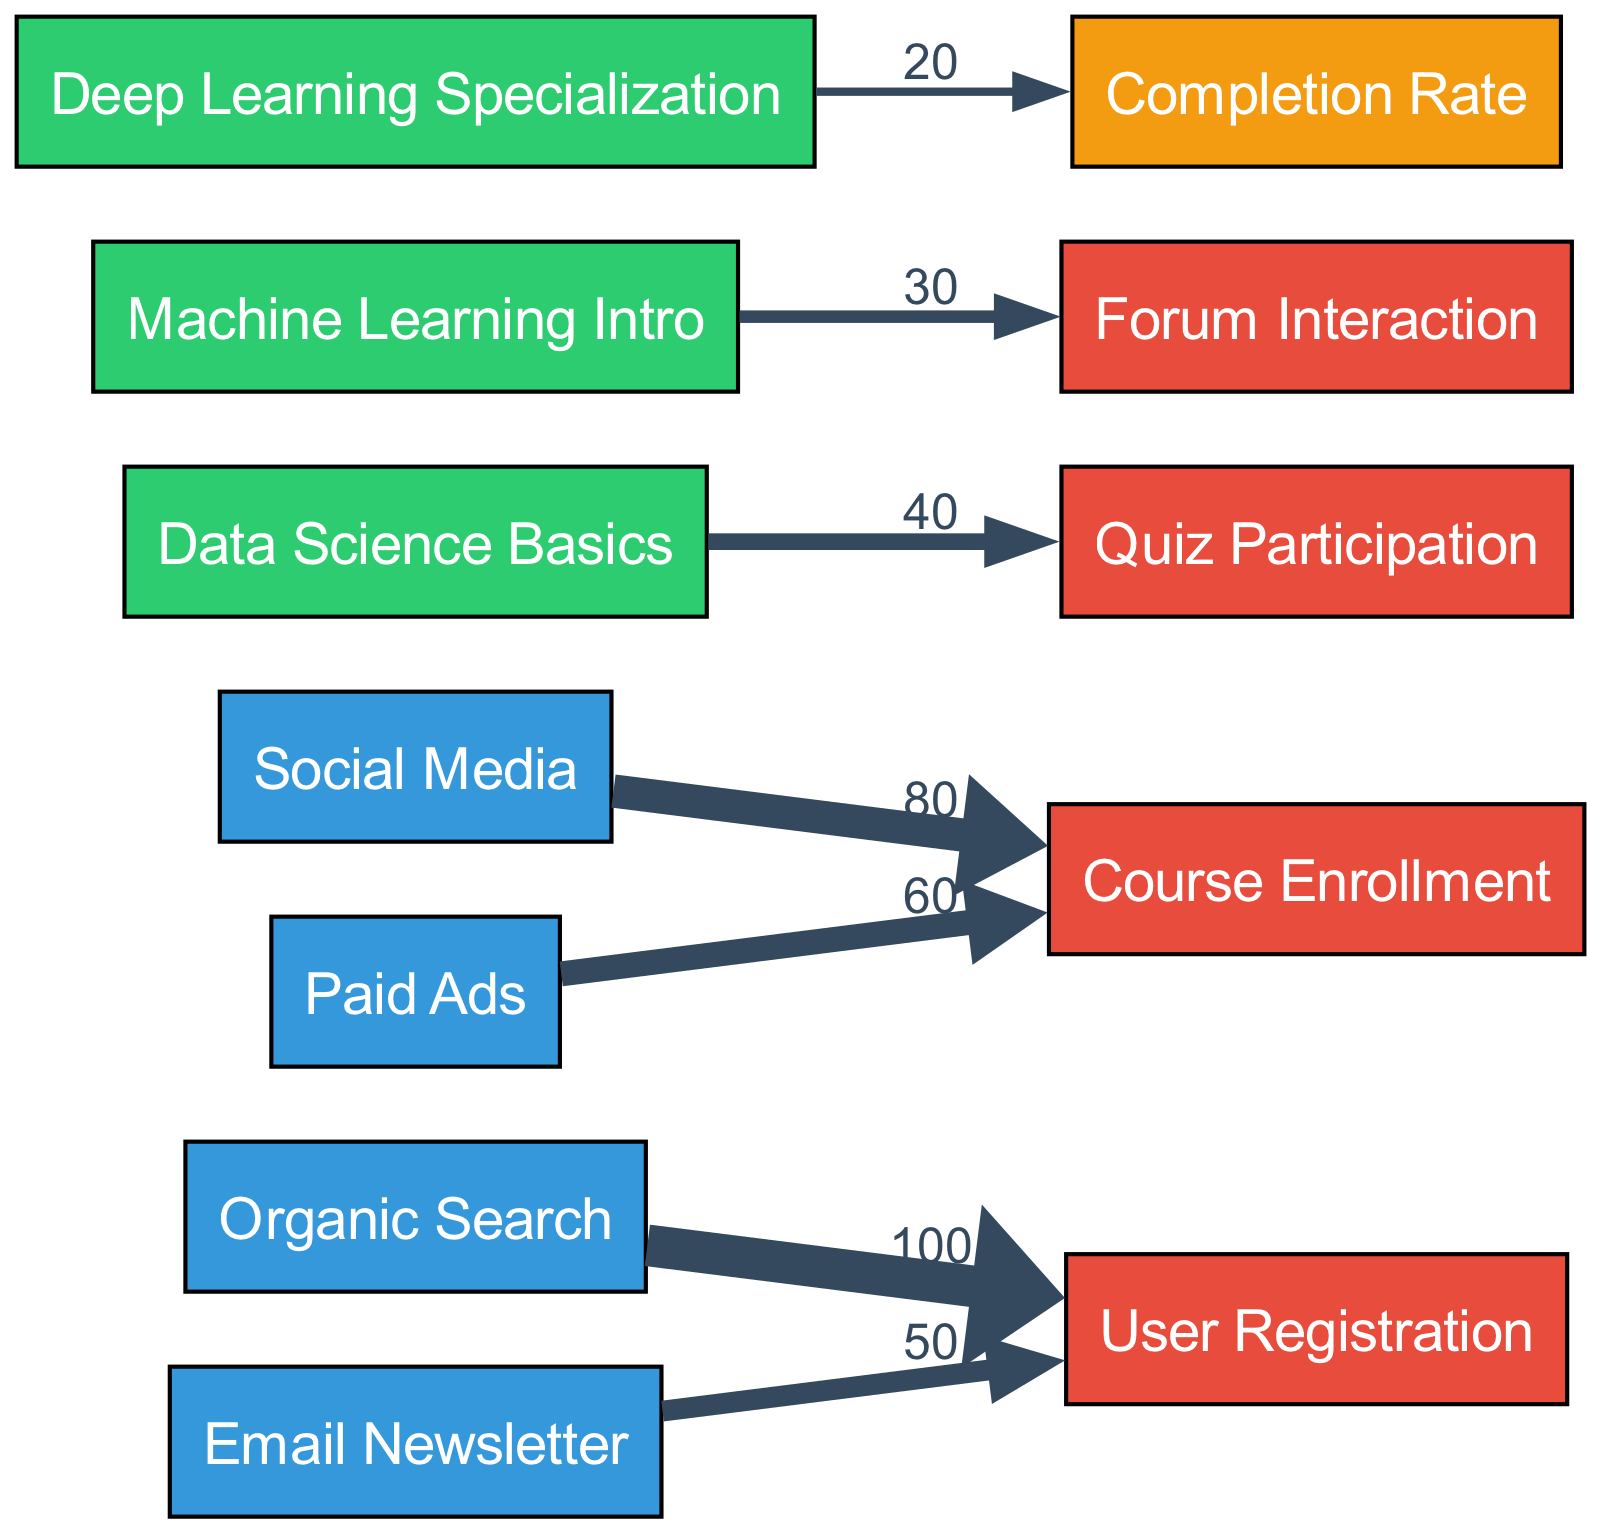What is the value of the edge from Organic Search to User Registration? The diagram shows a direct edge linking the node "Organic Search" to "User Registration" with a value of 100, indicating the number of users that registered via this traffic source.
Answer: 100 How many traffic sources are shown in the diagram? By counting the nodes labeled as "Traffic Source," we find four sources listed: Organic Search, Social Media, Email Newsletter, and Paid Ads, thus totaling four.
Answer: 4 Which course leads to the highest quiz participation? The "Data Science Basics" course has an edge to the "Quiz Participation" node with a value of 40, which is the highest among the courses in the diagram.
Answer: Data Science Basics What is the total value of course enrollments from Paid Ads and Social Media combined? The "Paid Ads" node has an edge to "Course Enrollment" with a value of 60, and "Social Media" has an edge to the same target with a value of 80. Adding these two gives 60 + 80 = 140.
Answer: 140 Which engagement activity has the lowest interaction rate? The diagram indicates that "Deep Learning Specialization" leads to a "Completion Rate" with a value of 20, making it the lowest engagement activity among the nodes shown.
Answer: Completion Rate What engagement activity is linked to the "Machine Learning Intro" course? The edge from "Machine Learning Intro" indicates it connects to "Forum Interaction" with a value of 30, making this interaction specific to that course.
Answer: Forum Interaction From which source do we get the most user registrations? The "Organic Search" source has the highest value link to "User Registration" (100), thus being the largest contributor in this metric.
Answer: Organic Search How many engagement nodes are connected to courses? There are three engagement nodes connected to courses: "Quiz Participation," "Forum Interaction," and "Completion Rate," thus totaling three nodes involved with courses.
Answer: 3 What is the total value of users registering from Email Newsletter and Organic Search combined? The values for "Email Newsletter" to "User Registration" is 50 and "Organic Search" to "User Registration" is 100. Adding these together results in 50 + 100 = 150.
Answer: 150 